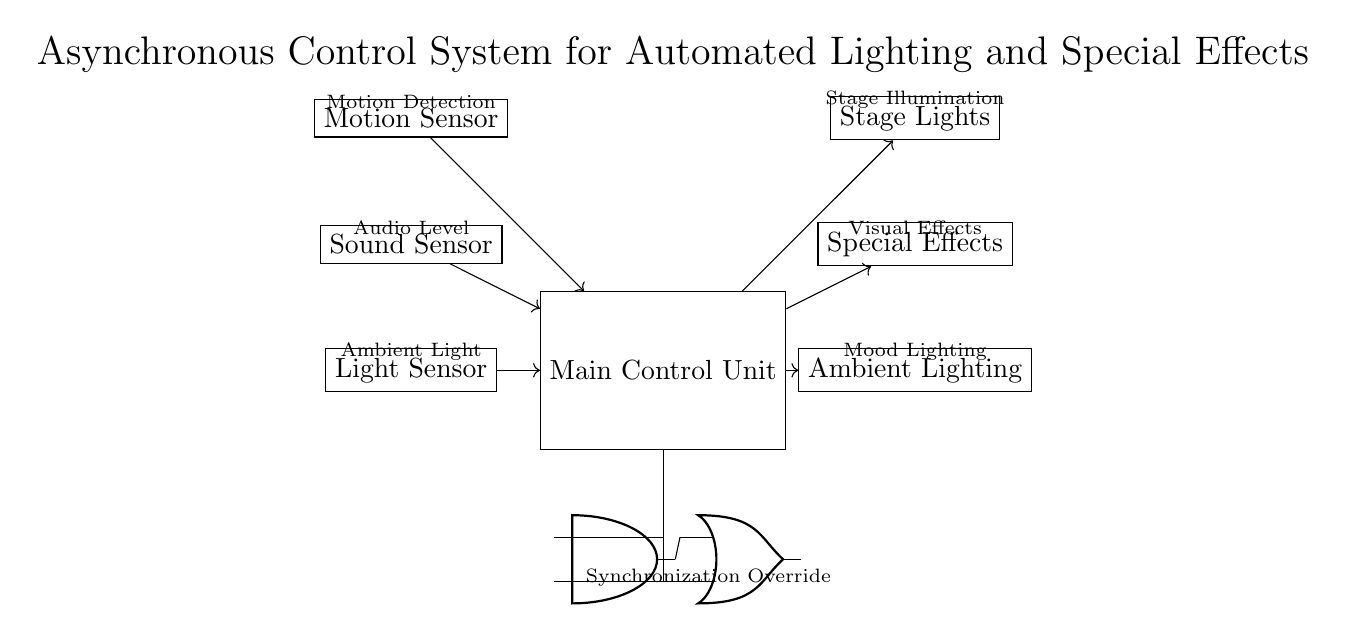What sensors are used in this circuit? The circuit diagram labels three sensors: Motion Sensor, Sound Sensor, and Light Sensor. These play a key role in determining the conditions under which the control unit operates to activate outputs.
Answer: Motion Sensor, Sound Sensor, Light Sensor What outputs are controlled by the Main Control Unit? The output devices indicated are Stage Lights, Special Effects, and Ambient Lighting, which are controlled based on inputs from the sensors.
Answer: Stage Lights, Special Effects, Ambient Lighting How many logic gates are present in the circuit? The circuit contains two logic gates: one AND gate and one OR gate. They are utilized for processing input signals from the Main Control Unit.
Answer: Two What is the function of the AND gate in this circuit? The AND gate receives inputs from the Main Control Unit and serves to ensure that certain conditions must be met for outputs to be activated, representing a synchronization requirement.
Answer: Synchronization What is the purpose of the OR gate in the control system? The OR gate allows for an override function, where if at least one input condition is met, it can activate an output regardless of the other gate's input status, providing flexibility.
Answer: Override Which components are connected directly to the Main Control Unit? The Main Control Unit is connected to all three sensors (Motion, Sound, and Light) as inputs and sends outputs to Stage Lights, Special Effects, and Ambient Lighting.
Answer: All sensors and outputs 